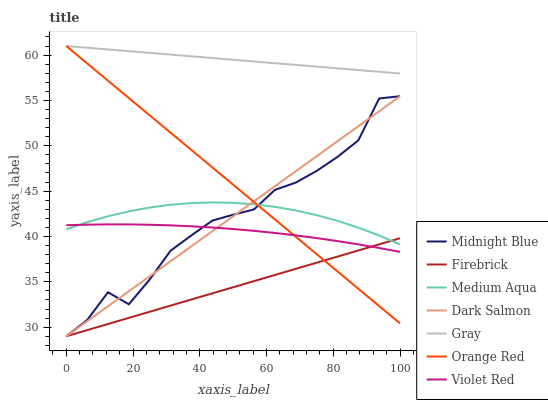Does Firebrick have the minimum area under the curve?
Answer yes or no. Yes. Does Gray have the maximum area under the curve?
Answer yes or no. Yes. Does Violet Red have the minimum area under the curve?
Answer yes or no. No. Does Violet Red have the maximum area under the curve?
Answer yes or no. No. Is Firebrick the smoothest?
Answer yes or no. Yes. Is Midnight Blue the roughest?
Answer yes or no. Yes. Is Violet Red the smoothest?
Answer yes or no. No. Is Violet Red the roughest?
Answer yes or no. No. Does Midnight Blue have the lowest value?
Answer yes or no. Yes. Does Violet Red have the lowest value?
Answer yes or no. No. Does Orange Red have the highest value?
Answer yes or no. Yes. Does Violet Red have the highest value?
Answer yes or no. No. Is Midnight Blue less than Gray?
Answer yes or no. Yes. Is Gray greater than Medium Aqua?
Answer yes or no. Yes. Does Dark Salmon intersect Medium Aqua?
Answer yes or no. Yes. Is Dark Salmon less than Medium Aqua?
Answer yes or no. No. Is Dark Salmon greater than Medium Aqua?
Answer yes or no. No. Does Midnight Blue intersect Gray?
Answer yes or no. No. 